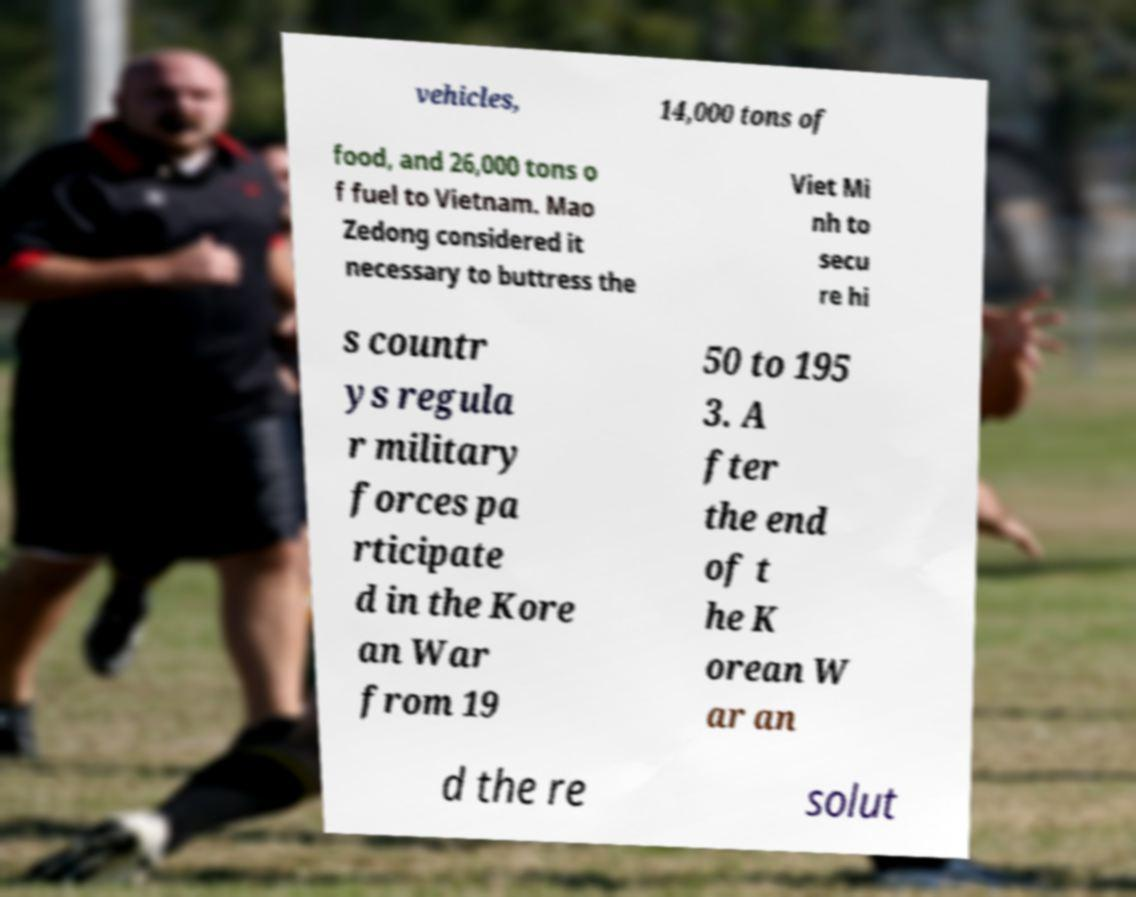For documentation purposes, I need the text within this image transcribed. Could you provide that? vehicles, 14,000 tons of food, and 26,000 tons o f fuel to Vietnam. Mao Zedong considered it necessary to buttress the Viet Mi nh to secu re hi s countr ys regula r military forces pa rticipate d in the Kore an War from 19 50 to 195 3. A fter the end of t he K orean W ar an d the re solut 